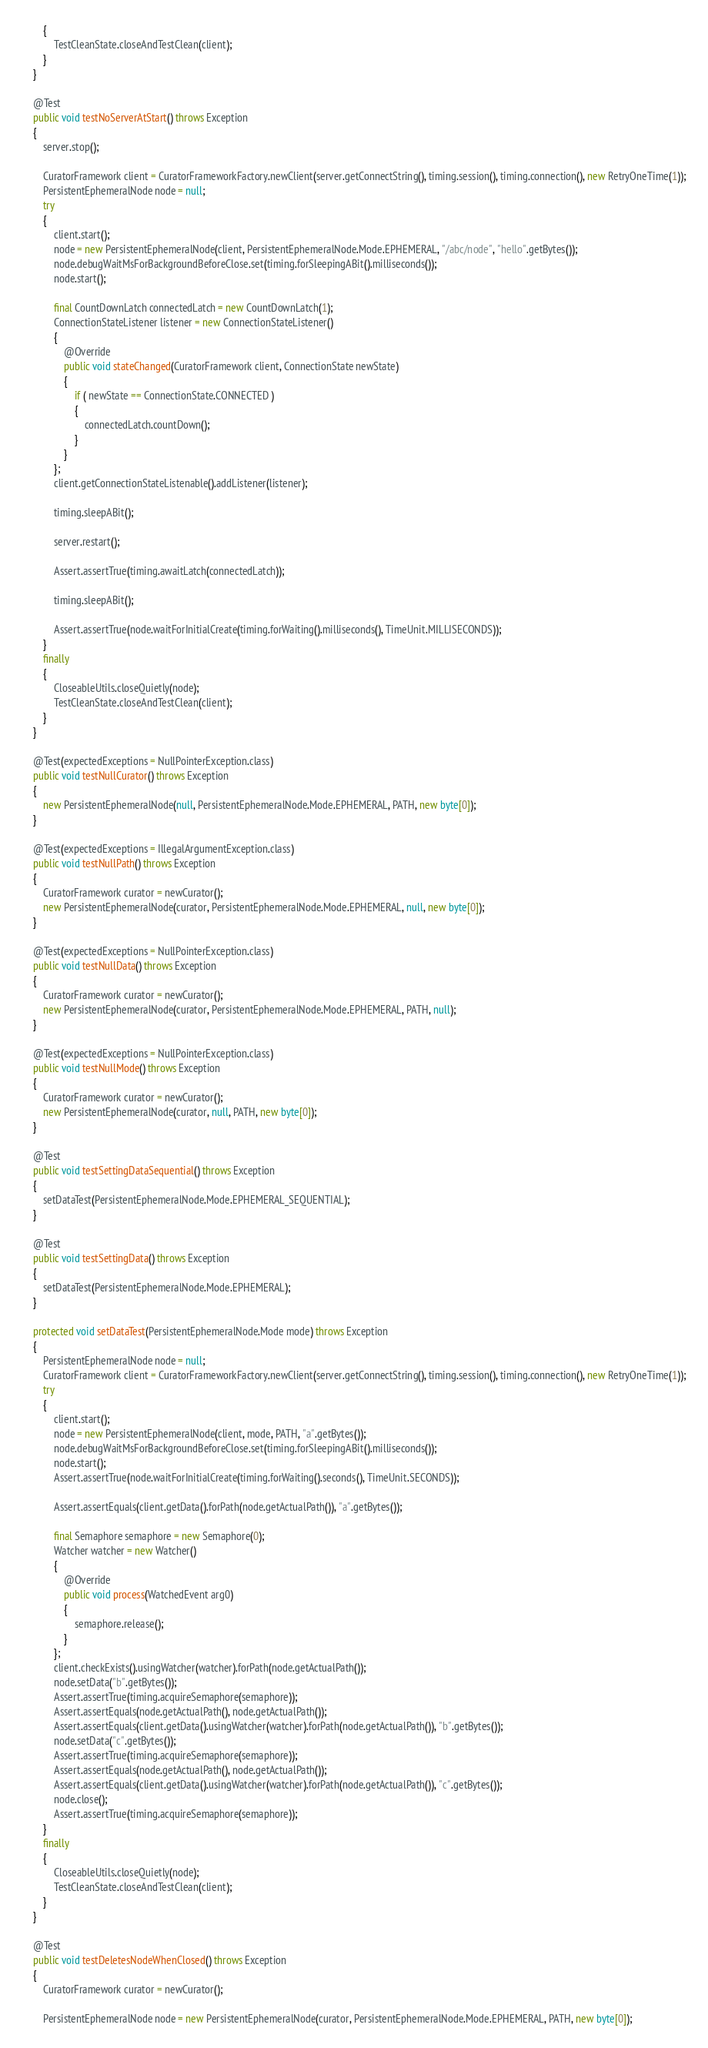<code> <loc_0><loc_0><loc_500><loc_500><_Java_>        {
            TestCleanState.closeAndTestClean(client);
        }
    }

    @Test
    public void testNoServerAtStart() throws Exception
    {
        server.stop();

        CuratorFramework client = CuratorFrameworkFactory.newClient(server.getConnectString(), timing.session(), timing.connection(), new RetryOneTime(1));
        PersistentEphemeralNode node = null;
        try
        {
            client.start();
            node = new PersistentEphemeralNode(client, PersistentEphemeralNode.Mode.EPHEMERAL, "/abc/node", "hello".getBytes());
            node.debugWaitMsForBackgroundBeforeClose.set(timing.forSleepingABit().milliseconds());
            node.start();

            final CountDownLatch connectedLatch = new CountDownLatch(1);
            ConnectionStateListener listener = new ConnectionStateListener()
            {
                @Override
                public void stateChanged(CuratorFramework client, ConnectionState newState)
                {
                    if ( newState == ConnectionState.CONNECTED )
                    {
                        connectedLatch.countDown();
                    }
                }
            };
            client.getConnectionStateListenable().addListener(listener);

            timing.sleepABit();

            server.restart();

            Assert.assertTrue(timing.awaitLatch(connectedLatch));

            timing.sleepABit();

            Assert.assertTrue(node.waitForInitialCreate(timing.forWaiting().milliseconds(), TimeUnit.MILLISECONDS));
        }
        finally
        {
            CloseableUtils.closeQuietly(node);
            TestCleanState.closeAndTestClean(client);
        }
    }

    @Test(expectedExceptions = NullPointerException.class)
    public void testNullCurator() throws Exception
    {
        new PersistentEphemeralNode(null, PersistentEphemeralNode.Mode.EPHEMERAL, PATH, new byte[0]);
    }

    @Test(expectedExceptions = IllegalArgumentException.class)
    public void testNullPath() throws Exception
    {
        CuratorFramework curator = newCurator();
        new PersistentEphemeralNode(curator, PersistentEphemeralNode.Mode.EPHEMERAL, null, new byte[0]);
    }

    @Test(expectedExceptions = NullPointerException.class)
    public void testNullData() throws Exception
    {
        CuratorFramework curator = newCurator();
        new PersistentEphemeralNode(curator, PersistentEphemeralNode.Mode.EPHEMERAL, PATH, null);
    }

    @Test(expectedExceptions = NullPointerException.class)
    public void testNullMode() throws Exception
    {
        CuratorFramework curator = newCurator();
        new PersistentEphemeralNode(curator, null, PATH, new byte[0]);
    }

    @Test
    public void testSettingDataSequential() throws Exception
    {
        setDataTest(PersistentEphemeralNode.Mode.EPHEMERAL_SEQUENTIAL);
    }

    @Test
    public void testSettingData() throws Exception
    {
        setDataTest(PersistentEphemeralNode.Mode.EPHEMERAL);
    }

    protected void setDataTest(PersistentEphemeralNode.Mode mode) throws Exception
    {
        PersistentEphemeralNode node = null;
        CuratorFramework client = CuratorFrameworkFactory.newClient(server.getConnectString(), timing.session(), timing.connection(), new RetryOneTime(1));
        try
        {
            client.start();
            node = new PersistentEphemeralNode(client, mode, PATH, "a".getBytes());
            node.debugWaitMsForBackgroundBeforeClose.set(timing.forSleepingABit().milliseconds());
            node.start();
            Assert.assertTrue(node.waitForInitialCreate(timing.forWaiting().seconds(), TimeUnit.SECONDS));

            Assert.assertEquals(client.getData().forPath(node.getActualPath()), "a".getBytes());

            final Semaphore semaphore = new Semaphore(0);
            Watcher watcher = new Watcher()
            {
                @Override
                public void process(WatchedEvent arg0)
                {
                    semaphore.release();
                }
            };
            client.checkExists().usingWatcher(watcher).forPath(node.getActualPath());
            node.setData("b".getBytes());
            Assert.assertTrue(timing.acquireSemaphore(semaphore));
            Assert.assertEquals(node.getActualPath(), node.getActualPath());
            Assert.assertEquals(client.getData().usingWatcher(watcher).forPath(node.getActualPath()), "b".getBytes());
            node.setData("c".getBytes());
            Assert.assertTrue(timing.acquireSemaphore(semaphore));
            Assert.assertEquals(node.getActualPath(), node.getActualPath());
            Assert.assertEquals(client.getData().usingWatcher(watcher).forPath(node.getActualPath()), "c".getBytes());
            node.close();
            Assert.assertTrue(timing.acquireSemaphore(semaphore));
        }
        finally
        {
            CloseableUtils.closeQuietly(node);
            TestCleanState.closeAndTestClean(client);
        }
    }

    @Test
    public void testDeletesNodeWhenClosed() throws Exception
    {
        CuratorFramework curator = newCurator();

        PersistentEphemeralNode node = new PersistentEphemeralNode(curator, PersistentEphemeralNode.Mode.EPHEMERAL, PATH, new byte[0]);</code> 